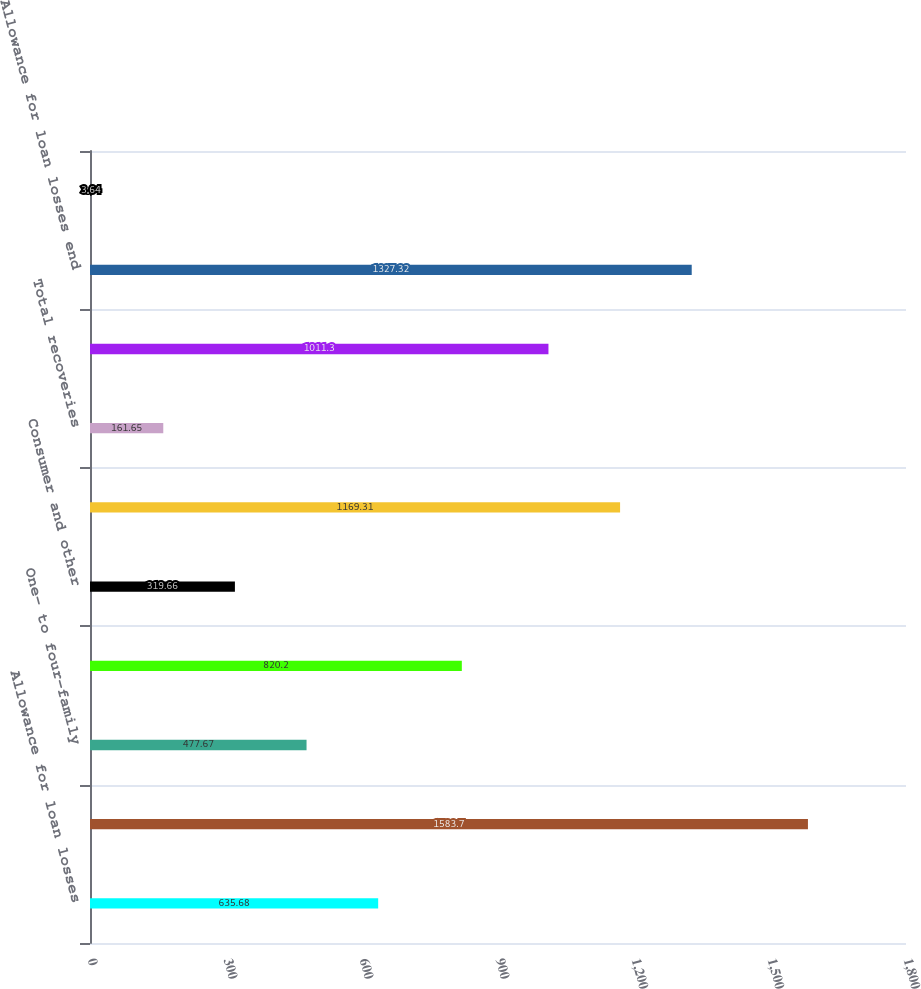Convert chart. <chart><loc_0><loc_0><loc_500><loc_500><bar_chart><fcel>Allowance for loan losses<fcel>Provision for loan losses<fcel>One- to four-family<fcel>Home equity<fcel>Consumer and other<fcel>Total charge-offs<fcel>Total recoveries<fcel>Net charge-offs<fcel>Allowance for loan losses end<fcel>Net charge-offs to average<nl><fcel>635.68<fcel>1583.7<fcel>477.67<fcel>820.2<fcel>319.66<fcel>1169.31<fcel>161.65<fcel>1011.3<fcel>1327.32<fcel>3.64<nl></chart> 